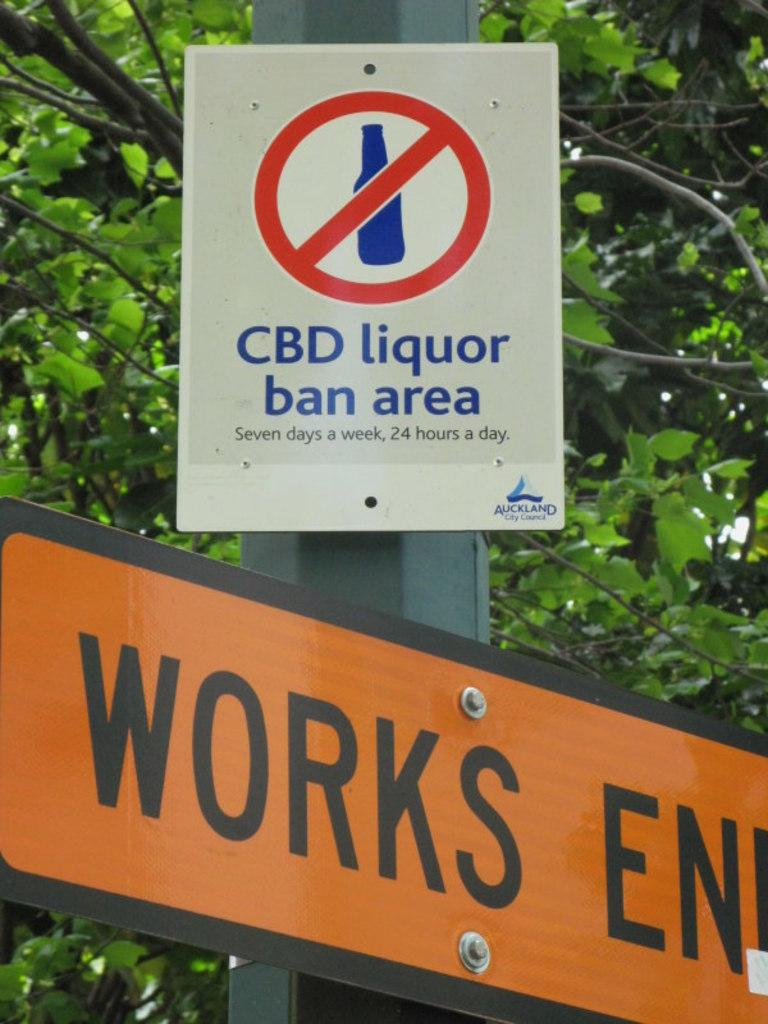<image>
Present a compact description of the photo's key features. White and blue sign that says "CBD liquod ban area". 